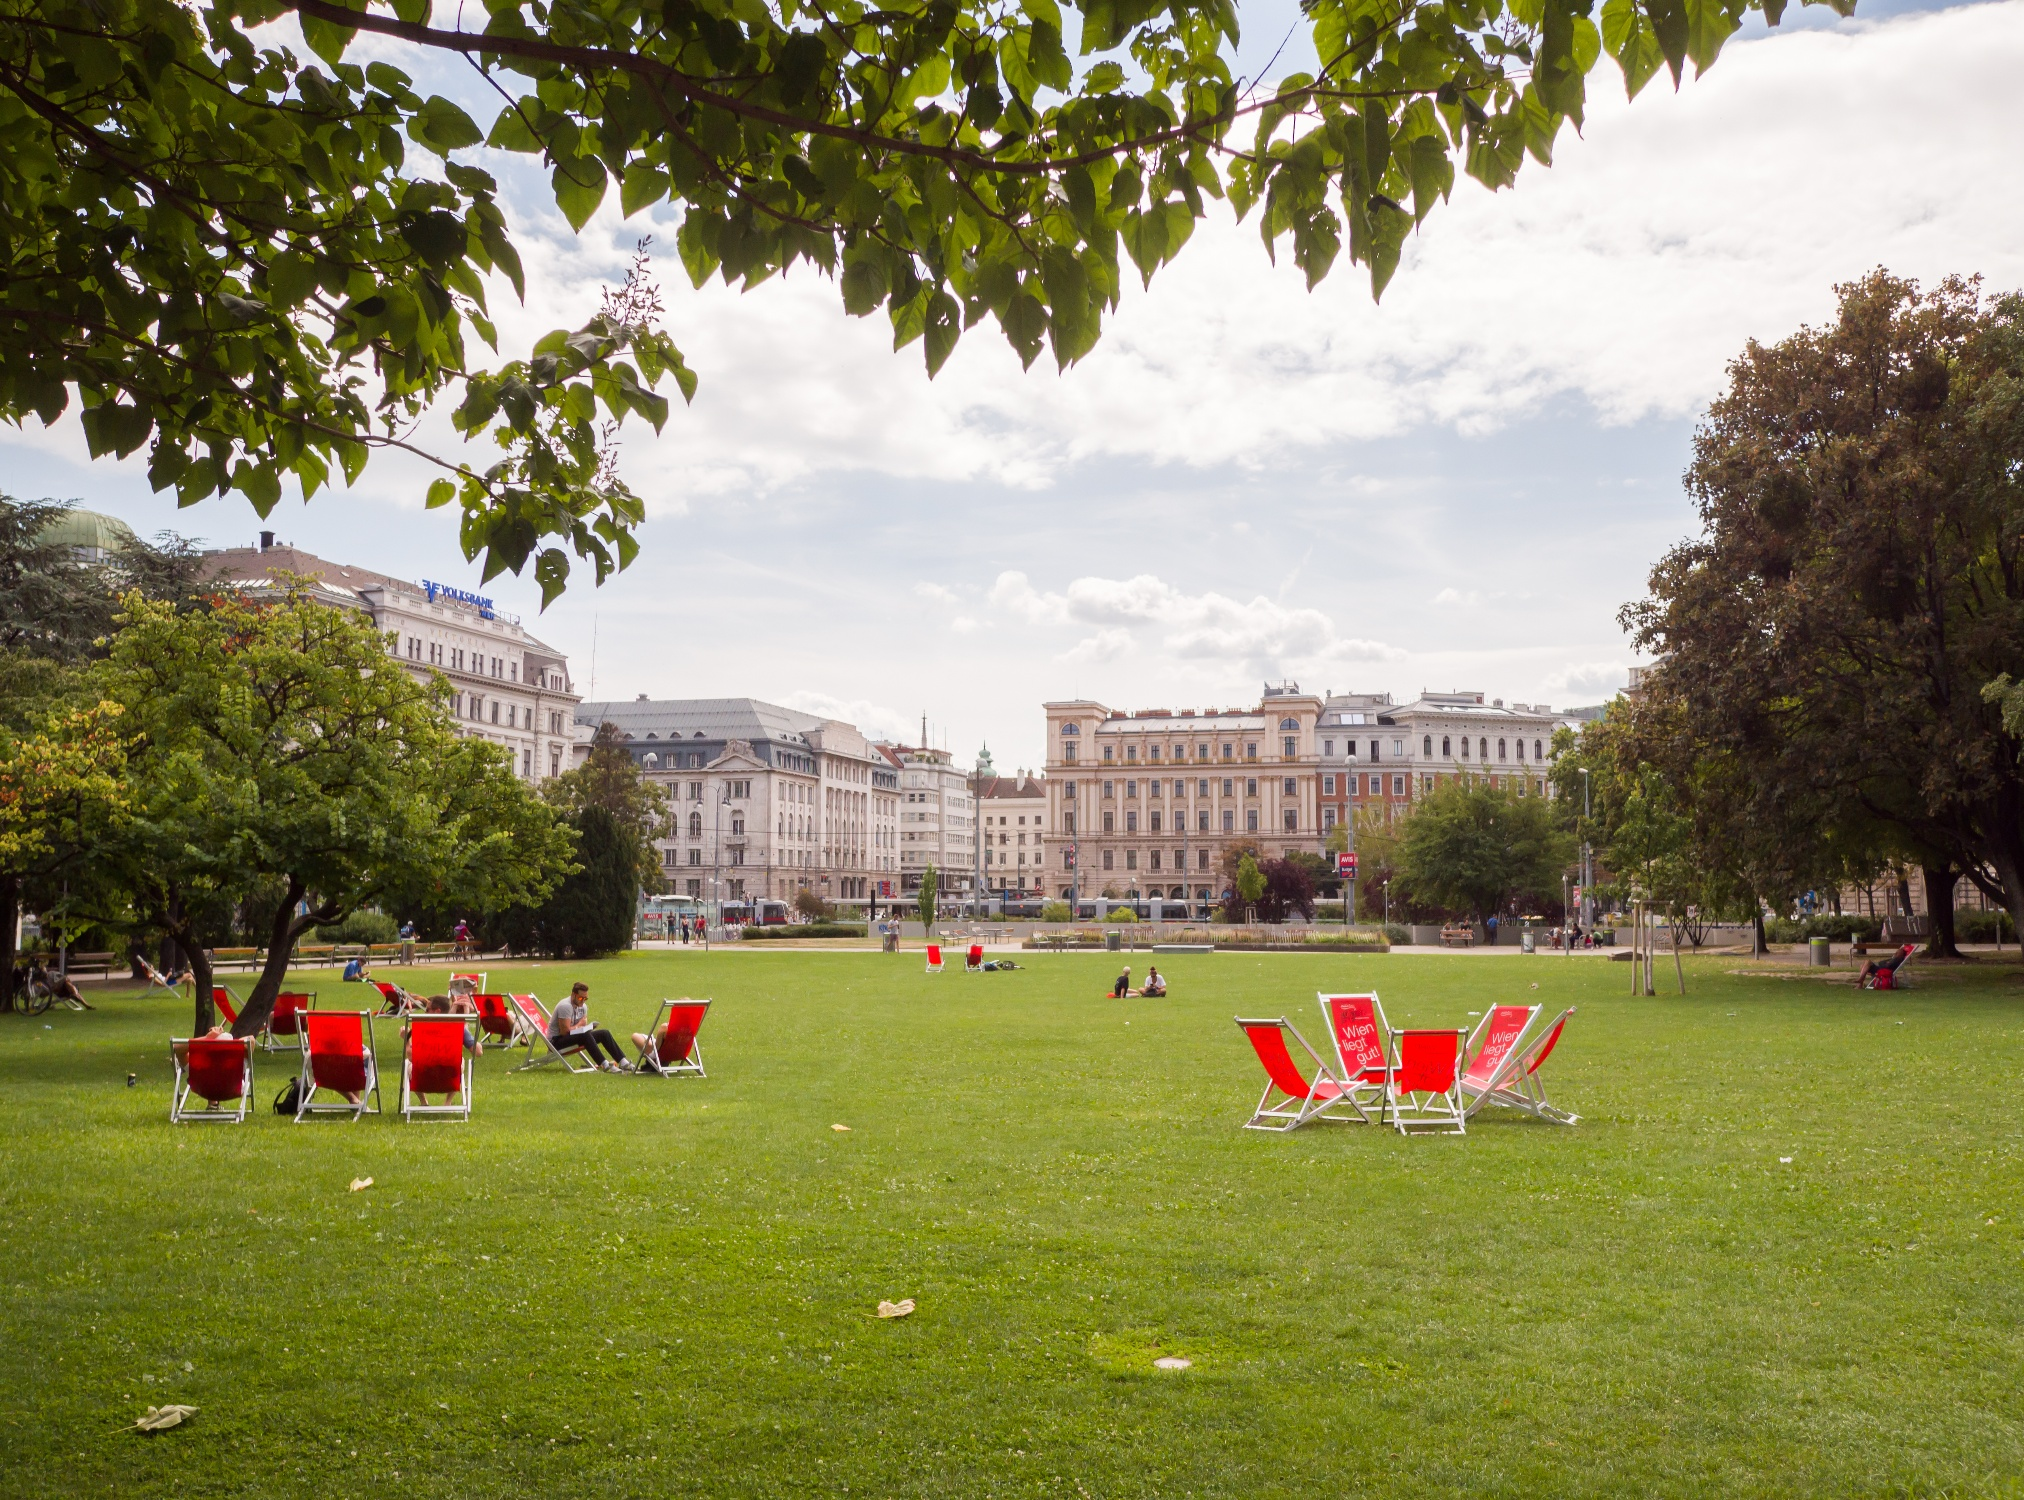Can you tell more about the historical significance of this park? Jardin Anglais, located in Geneva, has been a significant urban park since its establishment in the mid-19th century. Originally part of the city's enhancement projects, it serves not only as a recreational space but also as a cultural landmark, featuring sculptures and monuments like the famous L'Horloge Fleurie (Flower Clock) which symbolizes Geneva's watchmaking heritage. 